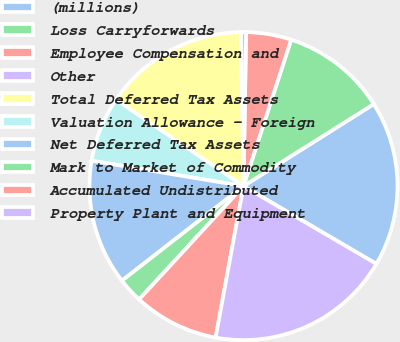Convert chart to OTSL. <chart><loc_0><loc_0><loc_500><loc_500><pie_chart><fcel>(millions)<fcel>Loss Carryforwards<fcel>Employee Compensation and<fcel>Other<fcel>Total Deferred Tax Assets<fcel>Valuation Allowance - Foreign<fcel>Net Deferred Tax Assets<fcel>Mark to Market of Commodity<fcel>Accumulated Undistributed<fcel>Property Plant and Equipment<nl><fcel>17.37%<fcel>11.05%<fcel>4.74%<fcel>0.53%<fcel>15.26%<fcel>6.84%<fcel>13.16%<fcel>2.63%<fcel>8.95%<fcel>19.47%<nl></chart> 